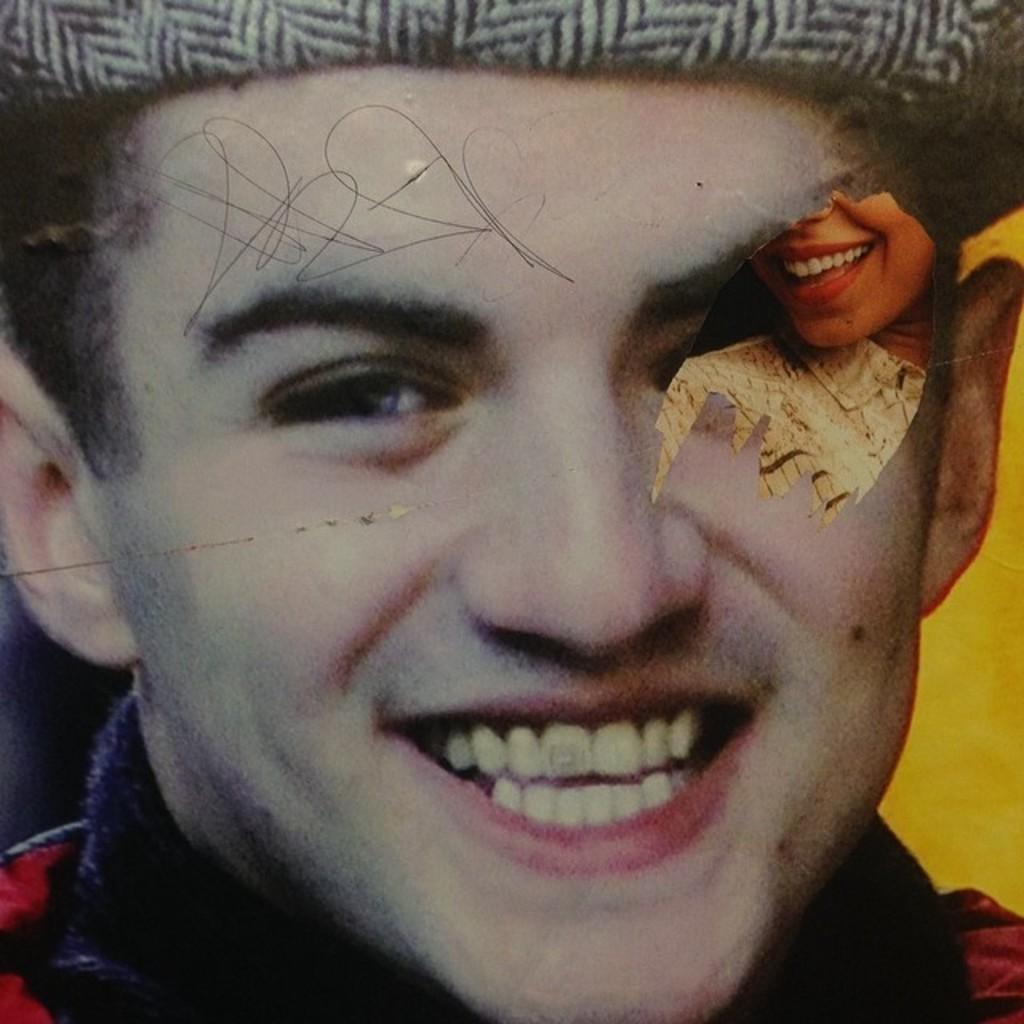Could you give a brief overview of what you see in this image? In this image there is a poster with a man and a woman's face with some scribbling on it. 